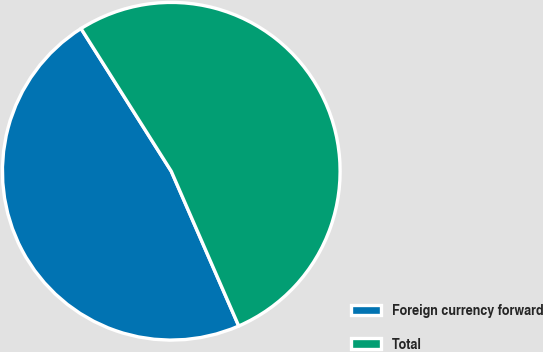Convert chart. <chart><loc_0><loc_0><loc_500><loc_500><pie_chart><fcel>Foreign currency forward<fcel>Total<nl><fcel>47.57%<fcel>52.43%<nl></chart> 